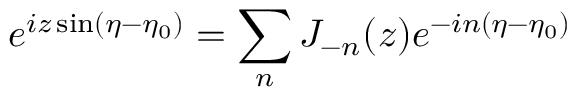<formula> <loc_0><loc_0><loc_500><loc_500>e ^ { i z \sin ( \eta - \eta _ { 0 } ) } = \sum _ { n } J _ { - n } ( z ) e ^ { - i n ( \eta - \eta _ { 0 } ) }</formula> 